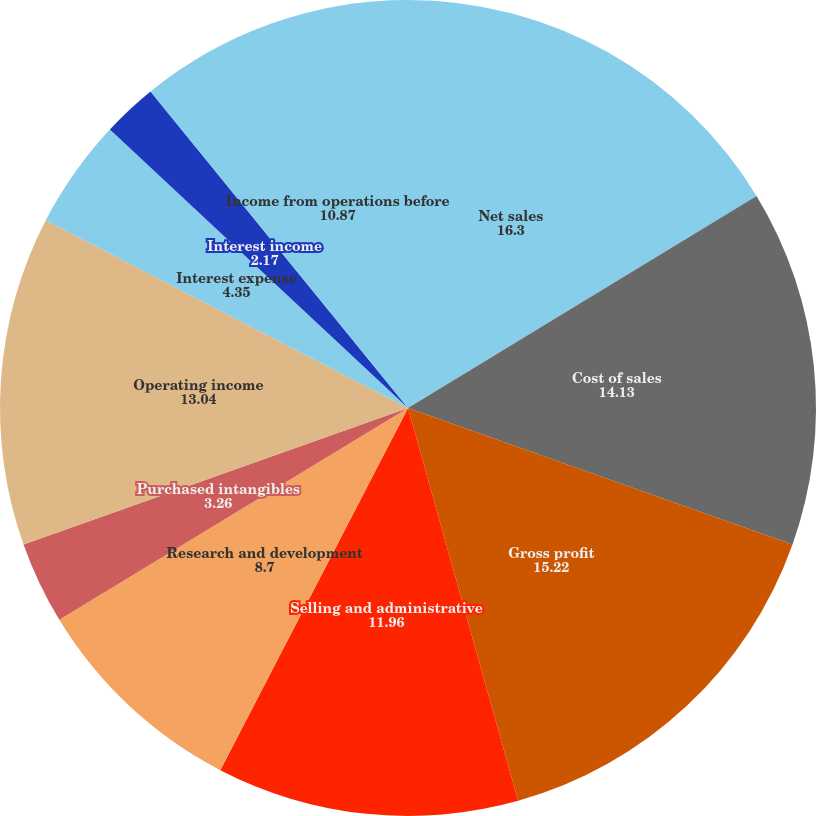Convert chart. <chart><loc_0><loc_0><loc_500><loc_500><pie_chart><fcel>Net sales<fcel>Cost of sales<fcel>Gross profit<fcel>Selling and administrative<fcel>Research and development<fcel>Purchased intangibles<fcel>Operating income<fcel>Interest expense<fcel>Interest income<fcel>Income from operations before<nl><fcel>16.3%<fcel>14.13%<fcel>15.22%<fcel>11.96%<fcel>8.7%<fcel>3.26%<fcel>13.04%<fcel>4.35%<fcel>2.17%<fcel>10.87%<nl></chart> 